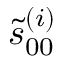Convert formula to latex. <formula><loc_0><loc_0><loc_500><loc_500>\tilde { s } _ { 0 0 } ^ { ( i ) }</formula> 